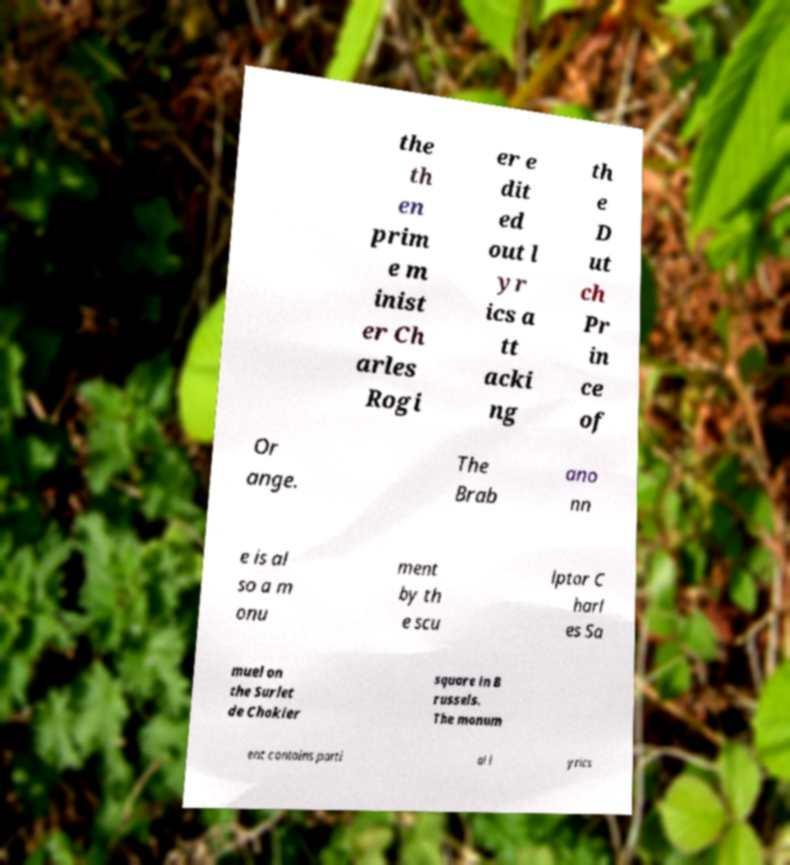I need the written content from this picture converted into text. Can you do that? the th en prim e m inist er Ch arles Rogi er e dit ed out l yr ics a tt acki ng th e D ut ch Pr in ce of Or ange. The Brab ano nn e is al so a m onu ment by th e scu lptor C harl es Sa muel on the Surlet de Chokier square in B russels. The monum ent contains parti al l yrics 